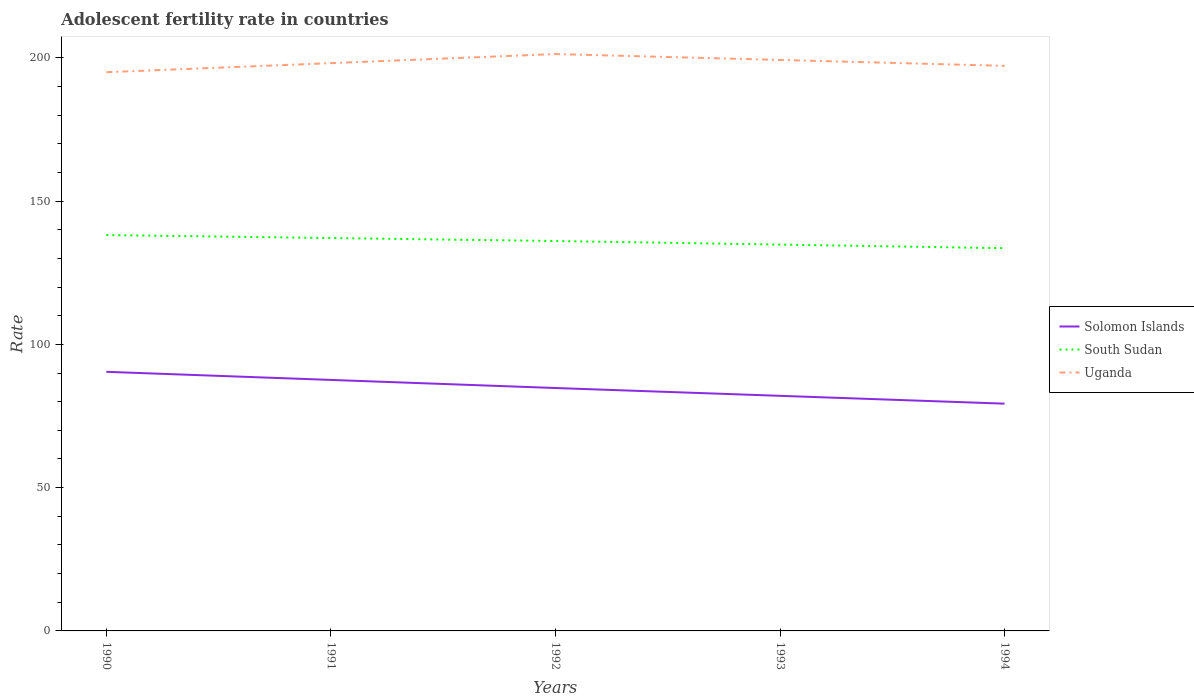How many different coloured lines are there?
Make the answer very short. 3. Does the line corresponding to Solomon Islands intersect with the line corresponding to Uganda?
Ensure brevity in your answer.  No. Is the number of lines equal to the number of legend labels?
Keep it short and to the point. Yes. Across all years, what is the maximum adolescent fertility rate in Solomon Islands?
Ensure brevity in your answer.  79.31. In which year was the adolescent fertility rate in South Sudan maximum?
Offer a very short reply. 1994. What is the total adolescent fertility rate in Solomon Islands in the graph?
Your answer should be very brief. 8.28. What is the difference between the highest and the second highest adolescent fertility rate in South Sudan?
Provide a short and direct response. 4.57. How many years are there in the graph?
Keep it short and to the point. 5. What is the difference between two consecutive major ticks on the Y-axis?
Offer a very short reply. 50. Does the graph contain any zero values?
Provide a short and direct response. No. How many legend labels are there?
Give a very brief answer. 3. How are the legend labels stacked?
Your answer should be compact. Vertical. What is the title of the graph?
Make the answer very short. Adolescent fertility rate in countries. What is the label or title of the Y-axis?
Your answer should be compact. Rate. What is the Rate of Solomon Islands in 1990?
Make the answer very short. 90.41. What is the Rate in South Sudan in 1990?
Offer a terse response. 138.13. What is the Rate in Uganda in 1990?
Ensure brevity in your answer.  194.96. What is the Rate in Solomon Islands in 1991?
Make the answer very short. 87.59. What is the Rate in South Sudan in 1991?
Provide a succinct answer. 137.1. What is the Rate in Uganda in 1991?
Your answer should be very brief. 198.13. What is the Rate of Solomon Islands in 1992?
Your answer should be compact. 84.76. What is the Rate in South Sudan in 1992?
Your answer should be very brief. 136.06. What is the Rate in Uganda in 1992?
Provide a short and direct response. 201.3. What is the Rate in Solomon Islands in 1993?
Your response must be concise. 82.03. What is the Rate in South Sudan in 1993?
Give a very brief answer. 134.81. What is the Rate of Uganda in 1993?
Make the answer very short. 199.24. What is the Rate in Solomon Islands in 1994?
Make the answer very short. 79.31. What is the Rate of South Sudan in 1994?
Provide a short and direct response. 133.56. What is the Rate in Uganda in 1994?
Your answer should be very brief. 197.18. Across all years, what is the maximum Rate in Solomon Islands?
Your answer should be compact. 90.41. Across all years, what is the maximum Rate in South Sudan?
Provide a succinct answer. 138.13. Across all years, what is the maximum Rate of Uganda?
Give a very brief answer. 201.3. Across all years, what is the minimum Rate of Solomon Islands?
Give a very brief answer. 79.31. Across all years, what is the minimum Rate in South Sudan?
Offer a very short reply. 133.56. Across all years, what is the minimum Rate in Uganda?
Your answer should be very brief. 194.96. What is the total Rate in Solomon Islands in the graph?
Provide a short and direct response. 424.1. What is the total Rate of South Sudan in the graph?
Your response must be concise. 679.66. What is the total Rate in Uganda in the graph?
Provide a short and direct response. 990.8. What is the difference between the Rate of Solomon Islands in 1990 and that in 1991?
Provide a short and direct response. 2.83. What is the difference between the Rate in South Sudan in 1990 and that in 1991?
Ensure brevity in your answer.  1.04. What is the difference between the Rate in Uganda in 1990 and that in 1991?
Keep it short and to the point. -3.17. What is the difference between the Rate in Solomon Islands in 1990 and that in 1992?
Your answer should be compact. 5.65. What is the difference between the Rate of South Sudan in 1990 and that in 1992?
Keep it short and to the point. 2.07. What is the difference between the Rate of Uganda in 1990 and that in 1992?
Your response must be concise. -6.34. What is the difference between the Rate in Solomon Islands in 1990 and that in 1993?
Your answer should be very brief. 8.38. What is the difference between the Rate of South Sudan in 1990 and that in 1993?
Ensure brevity in your answer.  3.32. What is the difference between the Rate of Uganda in 1990 and that in 1993?
Your answer should be very brief. -4.28. What is the difference between the Rate in Solomon Islands in 1990 and that in 1994?
Offer a very short reply. 11.11. What is the difference between the Rate of South Sudan in 1990 and that in 1994?
Your answer should be compact. 4.57. What is the difference between the Rate of Uganda in 1990 and that in 1994?
Provide a succinct answer. -2.23. What is the difference between the Rate of Solomon Islands in 1991 and that in 1992?
Keep it short and to the point. 2.83. What is the difference between the Rate of South Sudan in 1991 and that in 1992?
Provide a short and direct response. 1.04. What is the difference between the Rate of Uganda in 1991 and that in 1992?
Provide a succinct answer. -3.17. What is the difference between the Rate in Solomon Islands in 1991 and that in 1993?
Keep it short and to the point. 5.55. What is the difference between the Rate of South Sudan in 1991 and that in 1993?
Give a very brief answer. 2.29. What is the difference between the Rate in Uganda in 1991 and that in 1993?
Make the answer very short. -1.11. What is the difference between the Rate of Solomon Islands in 1991 and that in 1994?
Your answer should be compact. 8.28. What is the difference between the Rate of South Sudan in 1991 and that in 1994?
Your answer should be compact. 3.54. What is the difference between the Rate in Uganda in 1991 and that in 1994?
Ensure brevity in your answer.  0.94. What is the difference between the Rate in Solomon Islands in 1992 and that in 1993?
Make the answer very short. 2.73. What is the difference between the Rate in South Sudan in 1992 and that in 1993?
Provide a succinct answer. 1.25. What is the difference between the Rate in Uganda in 1992 and that in 1993?
Offer a terse response. 2.06. What is the difference between the Rate of Solomon Islands in 1992 and that in 1994?
Offer a very short reply. 5.46. What is the difference between the Rate in South Sudan in 1992 and that in 1994?
Ensure brevity in your answer.  2.5. What is the difference between the Rate in Uganda in 1992 and that in 1994?
Offer a terse response. 4.11. What is the difference between the Rate of Solomon Islands in 1993 and that in 1994?
Your response must be concise. 2.73. What is the difference between the Rate of South Sudan in 1993 and that in 1994?
Make the answer very short. 1.25. What is the difference between the Rate in Uganda in 1993 and that in 1994?
Ensure brevity in your answer.  2.06. What is the difference between the Rate in Solomon Islands in 1990 and the Rate in South Sudan in 1991?
Provide a short and direct response. -46.68. What is the difference between the Rate of Solomon Islands in 1990 and the Rate of Uganda in 1991?
Make the answer very short. -107.71. What is the difference between the Rate of South Sudan in 1990 and the Rate of Uganda in 1991?
Give a very brief answer. -59.99. What is the difference between the Rate of Solomon Islands in 1990 and the Rate of South Sudan in 1992?
Give a very brief answer. -45.64. What is the difference between the Rate of Solomon Islands in 1990 and the Rate of Uganda in 1992?
Make the answer very short. -110.88. What is the difference between the Rate in South Sudan in 1990 and the Rate in Uganda in 1992?
Your answer should be very brief. -63.16. What is the difference between the Rate of Solomon Islands in 1990 and the Rate of South Sudan in 1993?
Provide a succinct answer. -44.4. What is the difference between the Rate of Solomon Islands in 1990 and the Rate of Uganda in 1993?
Provide a succinct answer. -108.83. What is the difference between the Rate of South Sudan in 1990 and the Rate of Uganda in 1993?
Provide a short and direct response. -61.11. What is the difference between the Rate of Solomon Islands in 1990 and the Rate of South Sudan in 1994?
Offer a very short reply. -43.15. What is the difference between the Rate of Solomon Islands in 1990 and the Rate of Uganda in 1994?
Provide a short and direct response. -106.77. What is the difference between the Rate of South Sudan in 1990 and the Rate of Uganda in 1994?
Your response must be concise. -59.05. What is the difference between the Rate in Solomon Islands in 1991 and the Rate in South Sudan in 1992?
Your answer should be very brief. -48.47. What is the difference between the Rate of Solomon Islands in 1991 and the Rate of Uganda in 1992?
Offer a very short reply. -113.71. What is the difference between the Rate of South Sudan in 1991 and the Rate of Uganda in 1992?
Make the answer very short. -64.2. What is the difference between the Rate of Solomon Islands in 1991 and the Rate of South Sudan in 1993?
Your answer should be compact. -47.22. What is the difference between the Rate of Solomon Islands in 1991 and the Rate of Uganda in 1993?
Give a very brief answer. -111.65. What is the difference between the Rate in South Sudan in 1991 and the Rate in Uganda in 1993?
Your answer should be compact. -62.14. What is the difference between the Rate in Solomon Islands in 1991 and the Rate in South Sudan in 1994?
Keep it short and to the point. -45.97. What is the difference between the Rate in Solomon Islands in 1991 and the Rate in Uganda in 1994?
Offer a very short reply. -109.6. What is the difference between the Rate in South Sudan in 1991 and the Rate in Uganda in 1994?
Provide a succinct answer. -60.09. What is the difference between the Rate of Solomon Islands in 1992 and the Rate of South Sudan in 1993?
Your answer should be very brief. -50.05. What is the difference between the Rate of Solomon Islands in 1992 and the Rate of Uganda in 1993?
Keep it short and to the point. -114.48. What is the difference between the Rate of South Sudan in 1992 and the Rate of Uganda in 1993?
Ensure brevity in your answer.  -63.18. What is the difference between the Rate of Solomon Islands in 1992 and the Rate of South Sudan in 1994?
Make the answer very short. -48.8. What is the difference between the Rate in Solomon Islands in 1992 and the Rate in Uganda in 1994?
Ensure brevity in your answer.  -112.42. What is the difference between the Rate of South Sudan in 1992 and the Rate of Uganda in 1994?
Your answer should be compact. -61.12. What is the difference between the Rate in Solomon Islands in 1993 and the Rate in South Sudan in 1994?
Your answer should be very brief. -51.53. What is the difference between the Rate of Solomon Islands in 1993 and the Rate of Uganda in 1994?
Offer a very short reply. -115.15. What is the difference between the Rate of South Sudan in 1993 and the Rate of Uganda in 1994?
Provide a succinct answer. -62.37. What is the average Rate of Solomon Islands per year?
Provide a succinct answer. 84.82. What is the average Rate in South Sudan per year?
Provide a short and direct response. 135.93. What is the average Rate in Uganda per year?
Your answer should be very brief. 198.16. In the year 1990, what is the difference between the Rate of Solomon Islands and Rate of South Sudan?
Your response must be concise. -47.72. In the year 1990, what is the difference between the Rate in Solomon Islands and Rate in Uganda?
Your response must be concise. -104.54. In the year 1990, what is the difference between the Rate of South Sudan and Rate of Uganda?
Give a very brief answer. -56.83. In the year 1991, what is the difference between the Rate of Solomon Islands and Rate of South Sudan?
Your answer should be very brief. -49.51. In the year 1991, what is the difference between the Rate of Solomon Islands and Rate of Uganda?
Keep it short and to the point. -110.54. In the year 1991, what is the difference between the Rate in South Sudan and Rate in Uganda?
Keep it short and to the point. -61.03. In the year 1992, what is the difference between the Rate in Solomon Islands and Rate in South Sudan?
Keep it short and to the point. -51.3. In the year 1992, what is the difference between the Rate of Solomon Islands and Rate of Uganda?
Provide a succinct answer. -116.53. In the year 1992, what is the difference between the Rate of South Sudan and Rate of Uganda?
Ensure brevity in your answer.  -65.24. In the year 1993, what is the difference between the Rate of Solomon Islands and Rate of South Sudan?
Keep it short and to the point. -52.78. In the year 1993, what is the difference between the Rate of Solomon Islands and Rate of Uganda?
Offer a very short reply. -117.21. In the year 1993, what is the difference between the Rate in South Sudan and Rate in Uganda?
Your response must be concise. -64.43. In the year 1994, what is the difference between the Rate in Solomon Islands and Rate in South Sudan?
Offer a terse response. -54.25. In the year 1994, what is the difference between the Rate of Solomon Islands and Rate of Uganda?
Your response must be concise. -117.88. In the year 1994, what is the difference between the Rate in South Sudan and Rate in Uganda?
Make the answer very short. -63.62. What is the ratio of the Rate in Solomon Islands in 1990 to that in 1991?
Give a very brief answer. 1.03. What is the ratio of the Rate of South Sudan in 1990 to that in 1991?
Provide a short and direct response. 1.01. What is the ratio of the Rate in Solomon Islands in 1990 to that in 1992?
Offer a terse response. 1.07. What is the ratio of the Rate in South Sudan in 1990 to that in 1992?
Give a very brief answer. 1.02. What is the ratio of the Rate in Uganda in 1990 to that in 1992?
Your response must be concise. 0.97. What is the ratio of the Rate of Solomon Islands in 1990 to that in 1993?
Provide a succinct answer. 1.1. What is the ratio of the Rate in South Sudan in 1990 to that in 1993?
Keep it short and to the point. 1.02. What is the ratio of the Rate of Uganda in 1990 to that in 1993?
Your response must be concise. 0.98. What is the ratio of the Rate in Solomon Islands in 1990 to that in 1994?
Your answer should be compact. 1.14. What is the ratio of the Rate of South Sudan in 1990 to that in 1994?
Offer a terse response. 1.03. What is the ratio of the Rate of Uganda in 1990 to that in 1994?
Your answer should be compact. 0.99. What is the ratio of the Rate of South Sudan in 1991 to that in 1992?
Keep it short and to the point. 1.01. What is the ratio of the Rate of Uganda in 1991 to that in 1992?
Provide a succinct answer. 0.98. What is the ratio of the Rate in Solomon Islands in 1991 to that in 1993?
Offer a very short reply. 1.07. What is the ratio of the Rate in Uganda in 1991 to that in 1993?
Your response must be concise. 0.99. What is the ratio of the Rate in Solomon Islands in 1991 to that in 1994?
Provide a short and direct response. 1.1. What is the ratio of the Rate in South Sudan in 1991 to that in 1994?
Your response must be concise. 1.03. What is the ratio of the Rate in Solomon Islands in 1992 to that in 1993?
Keep it short and to the point. 1.03. What is the ratio of the Rate in South Sudan in 1992 to that in 1993?
Provide a short and direct response. 1.01. What is the ratio of the Rate in Uganda in 1992 to that in 1993?
Provide a short and direct response. 1.01. What is the ratio of the Rate of Solomon Islands in 1992 to that in 1994?
Make the answer very short. 1.07. What is the ratio of the Rate in South Sudan in 1992 to that in 1994?
Offer a terse response. 1.02. What is the ratio of the Rate of Uganda in 1992 to that in 1994?
Give a very brief answer. 1.02. What is the ratio of the Rate of Solomon Islands in 1993 to that in 1994?
Make the answer very short. 1.03. What is the ratio of the Rate in South Sudan in 1993 to that in 1994?
Your answer should be compact. 1.01. What is the ratio of the Rate of Uganda in 1993 to that in 1994?
Provide a short and direct response. 1.01. What is the difference between the highest and the second highest Rate of Solomon Islands?
Your answer should be very brief. 2.83. What is the difference between the highest and the second highest Rate in South Sudan?
Ensure brevity in your answer.  1.04. What is the difference between the highest and the second highest Rate of Uganda?
Make the answer very short. 2.06. What is the difference between the highest and the lowest Rate in Solomon Islands?
Ensure brevity in your answer.  11.11. What is the difference between the highest and the lowest Rate of South Sudan?
Provide a short and direct response. 4.57. What is the difference between the highest and the lowest Rate of Uganda?
Provide a succinct answer. 6.34. 